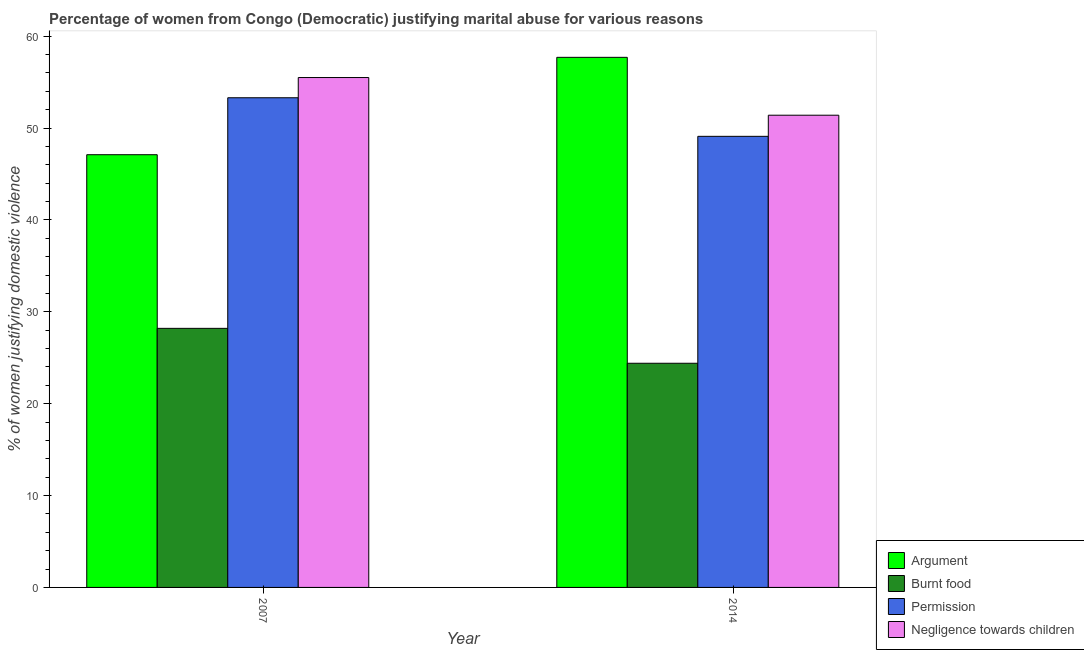How many groups of bars are there?
Your answer should be compact. 2. Are the number of bars on each tick of the X-axis equal?
Provide a short and direct response. Yes. In how many cases, is the number of bars for a given year not equal to the number of legend labels?
Your answer should be very brief. 0. What is the percentage of women justifying abuse for going without permission in 2014?
Your answer should be compact. 49.1. Across all years, what is the maximum percentage of women justifying abuse for burning food?
Your response must be concise. 28.2. Across all years, what is the minimum percentage of women justifying abuse for showing negligence towards children?
Your response must be concise. 51.4. In which year was the percentage of women justifying abuse for showing negligence towards children maximum?
Keep it short and to the point. 2007. In which year was the percentage of women justifying abuse for going without permission minimum?
Your response must be concise. 2014. What is the total percentage of women justifying abuse for burning food in the graph?
Your answer should be very brief. 52.6. What is the difference between the percentage of women justifying abuse in the case of an argument in 2007 and that in 2014?
Your response must be concise. -10.6. What is the difference between the percentage of women justifying abuse for going without permission in 2014 and the percentage of women justifying abuse for showing negligence towards children in 2007?
Provide a succinct answer. -4.2. What is the average percentage of women justifying abuse for going without permission per year?
Keep it short and to the point. 51.2. In the year 2014, what is the difference between the percentage of women justifying abuse for showing negligence towards children and percentage of women justifying abuse for going without permission?
Your answer should be very brief. 0. In how many years, is the percentage of women justifying abuse for showing negligence towards children greater than 48 %?
Make the answer very short. 2. What is the ratio of the percentage of women justifying abuse for burning food in 2007 to that in 2014?
Provide a succinct answer. 1.16. In how many years, is the percentage of women justifying abuse in the case of an argument greater than the average percentage of women justifying abuse in the case of an argument taken over all years?
Offer a terse response. 1. What does the 4th bar from the left in 2007 represents?
Offer a very short reply. Negligence towards children. What does the 3rd bar from the right in 2007 represents?
Your response must be concise. Burnt food. Are all the bars in the graph horizontal?
Make the answer very short. No. Are the values on the major ticks of Y-axis written in scientific E-notation?
Offer a terse response. No. Does the graph contain any zero values?
Your response must be concise. No. How many legend labels are there?
Your answer should be compact. 4. How are the legend labels stacked?
Offer a very short reply. Vertical. What is the title of the graph?
Give a very brief answer. Percentage of women from Congo (Democratic) justifying marital abuse for various reasons. What is the label or title of the X-axis?
Give a very brief answer. Year. What is the label or title of the Y-axis?
Your answer should be compact. % of women justifying domestic violence. What is the % of women justifying domestic violence of Argument in 2007?
Your answer should be very brief. 47.1. What is the % of women justifying domestic violence of Burnt food in 2007?
Your answer should be compact. 28.2. What is the % of women justifying domestic violence in Permission in 2007?
Keep it short and to the point. 53.3. What is the % of women justifying domestic violence of Negligence towards children in 2007?
Your answer should be very brief. 55.5. What is the % of women justifying domestic violence of Argument in 2014?
Offer a very short reply. 57.7. What is the % of women justifying domestic violence of Burnt food in 2014?
Keep it short and to the point. 24.4. What is the % of women justifying domestic violence of Permission in 2014?
Provide a succinct answer. 49.1. What is the % of women justifying domestic violence of Negligence towards children in 2014?
Make the answer very short. 51.4. Across all years, what is the maximum % of women justifying domestic violence of Argument?
Provide a succinct answer. 57.7. Across all years, what is the maximum % of women justifying domestic violence in Burnt food?
Make the answer very short. 28.2. Across all years, what is the maximum % of women justifying domestic violence of Permission?
Offer a terse response. 53.3. Across all years, what is the maximum % of women justifying domestic violence of Negligence towards children?
Your response must be concise. 55.5. Across all years, what is the minimum % of women justifying domestic violence in Argument?
Keep it short and to the point. 47.1. Across all years, what is the minimum % of women justifying domestic violence of Burnt food?
Offer a terse response. 24.4. Across all years, what is the minimum % of women justifying domestic violence in Permission?
Make the answer very short. 49.1. Across all years, what is the minimum % of women justifying domestic violence in Negligence towards children?
Your answer should be very brief. 51.4. What is the total % of women justifying domestic violence of Argument in the graph?
Provide a succinct answer. 104.8. What is the total % of women justifying domestic violence of Burnt food in the graph?
Provide a succinct answer. 52.6. What is the total % of women justifying domestic violence of Permission in the graph?
Ensure brevity in your answer.  102.4. What is the total % of women justifying domestic violence in Negligence towards children in the graph?
Your answer should be compact. 106.9. What is the difference between the % of women justifying domestic violence in Argument in 2007 and that in 2014?
Your answer should be compact. -10.6. What is the difference between the % of women justifying domestic violence in Burnt food in 2007 and that in 2014?
Keep it short and to the point. 3.8. What is the difference between the % of women justifying domestic violence of Permission in 2007 and that in 2014?
Your answer should be very brief. 4.2. What is the difference between the % of women justifying domestic violence of Negligence towards children in 2007 and that in 2014?
Make the answer very short. 4.1. What is the difference between the % of women justifying domestic violence in Argument in 2007 and the % of women justifying domestic violence in Burnt food in 2014?
Your answer should be very brief. 22.7. What is the difference between the % of women justifying domestic violence in Argument in 2007 and the % of women justifying domestic violence in Permission in 2014?
Make the answer very short. -2. What is the difference between the % of women justifying domestic violence of Argument in 2007 and the % of women justifying domestic violence of Negligence towards children in 2014?
Keep it short and to the point. -4.3. What is the difference between the % of women justifying domestic violence in Burnt food in 2007 and the % of women justifying domestic violence in Permission in 2014?
Offer a terse response. -20.9. What is the difference between the % of women justifying domestic violence of Burnt food in 2007 and the % of women justifying domestic violence of Negligence towards children in 2014?
Give a very brief answer. -23.2. What is the difference between the % of women justifying domestic violence of Permission in 2007 and the % of women justifying domestic violence of Negligence towards children in 2014?
Give a very brief answer. 1.9. What is the average % of women justifying domestic violence in Argument per year?
Keep it short and to the point. 52.4. What is the average % of women justifying domestic violence of Burnt food per year?
Provide a succinct answer. 26.3. What is the average % of women justifying domestic violence of Permission per year?
Offer a terse response. 51.2. What is the average % of women justifying domestic violence in Negligence towards children per year?
Provide a short and direct response. 53.45. In the year 2007, what is the difference between the % of women justifying domestic violence of Argument and % of women justifying domestic violence of Permission?
Offer a very short reply. -6.2. In the year 2007, what is the difference between the % of women justifying domestic violence in Burnt food and % of women justifying domestic violence in Permission?
Give a very brief answer. -25.1. In the year 2007, what is the difference between the % of women justifying domestic violence of Burnt food and % of women justifying domestic violence of Negligence towards children?
Offer a very short reply. -27.3. In the year 2014, what is the difference between the % of women justifying domestic violence in Argument and % of women justifying domestic violence in Burnt food?
Provide a succinct answer. 33.3. In the year 2014, what is the difference between the % of women justifying domestic violence in Argument and % of women justifying domestic violence in Negligence towards children?
Make the answer very short. 6.3. In the year 2014, what is the difference between the % of women justifying domestic violence of Burnt food and % of women justifying domestic violence of Permission?
Ensure brevity in your answer.  -24.7. In the year 2014, what is the difference between the % of women justifying domestic violence in Burnt food and % of women justifying domestic violence in Negligence towards children?
Your answer should be very brief. -27. What is the ratio of the % of women justifying domestic violence of Argument in 2007 to that in 2014?
Give a very brief answer. 0.82. What is the ratio of the % of women justifying domestic violence of Burnt food in 2007 to that in 2014?
Make the answer very short. 1.16. What is the ratio of the % of women justifying domestic violence of Permission in 2007 to that in 2014?
Your answer should be very brief. 1.09. What is the ratio of the % of women justifying domestic violence of Negligence towards children in 2007 to that in 2014?
Ensure brevity in your answer.  1.08. What is the difference between the highest and the second highest % of women justifying domestic violence in Argument?
Give a very brief answer. 10.6. What is the difference between the highest and the second highest % of women justifying domestic violence of Burnt food?
Keep it short and to the point. 3.8. What is the difference between the highest and the second highest % of women justifying domestic violence of Negligence towards children?
Offer a very short reply. 4.1. What is the difference between the highest and the lowest % of women justifying domestic violence in Permission?
Offer a terse response. 4.2. 